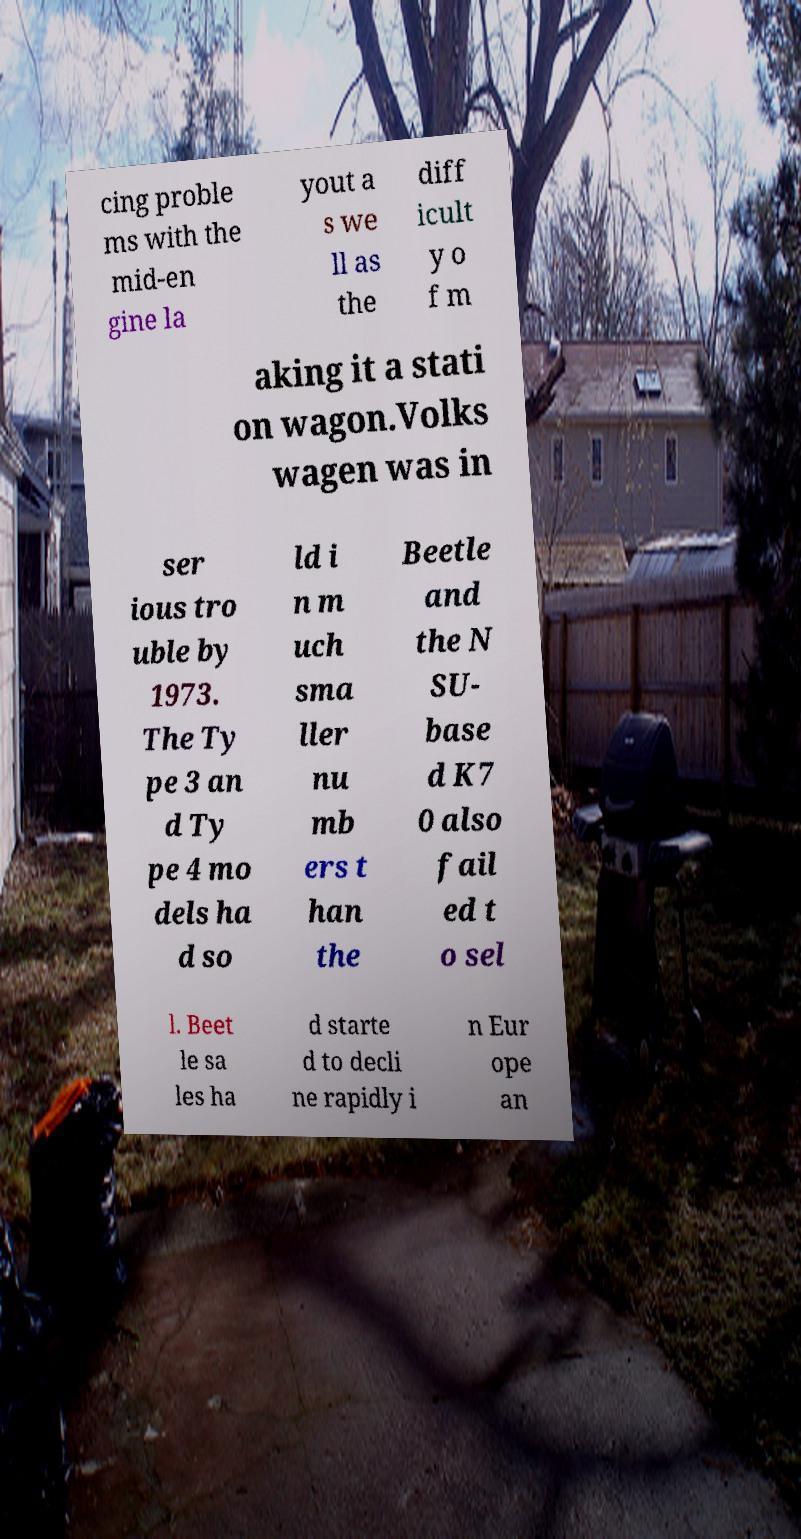There's text embedded in this image that I need extracted. Can you transcribe it verbatim? cing proble ms with the mid-en gine la yout a s we ll as the diff icult y o f m aking it a stati on wagon.Volks wagen was in ser ious tro uble by 1973. The Ty pe 3 an d Ty pe 4 mo dels ha d so ld i n m uch sma ller nu mb ers t han the Beetle and the N SU- base d K7 0 also fail ed t o sel l. Beet le sa les ha d starte d to decli ne rapidly i n Eur ope an 